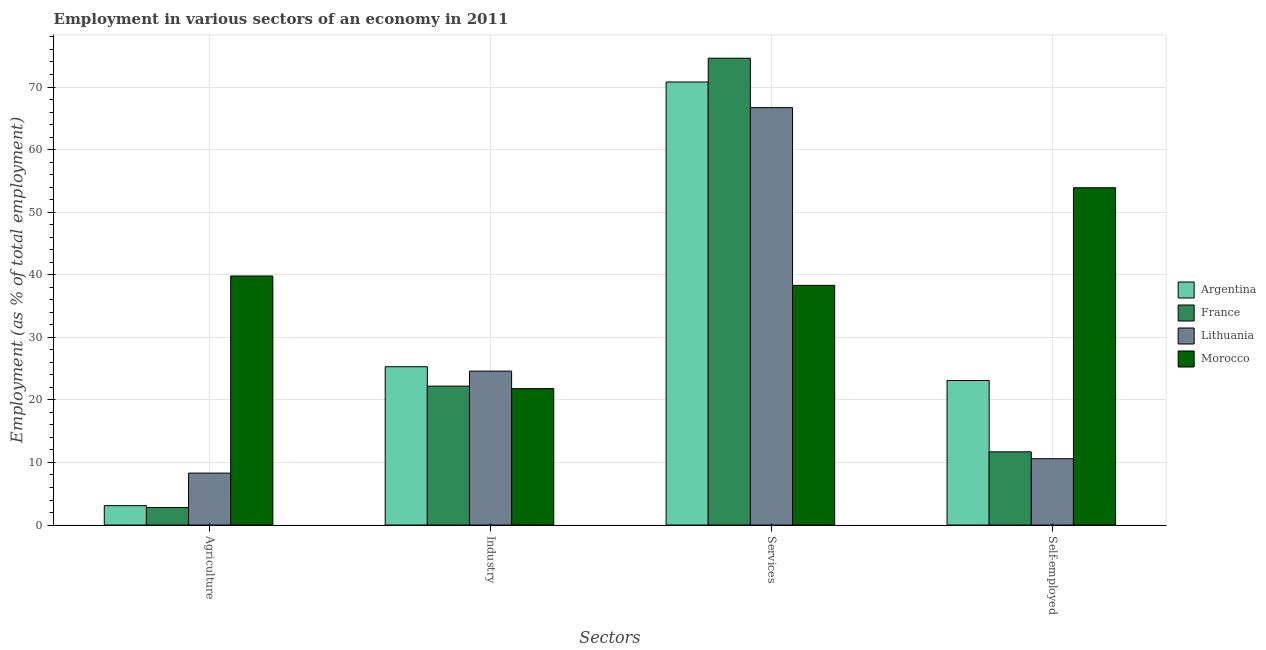Are the number of bars on each tick of the X-axis equal?
Keep it short and to the point. Yes. How many bars are there on the 2nd tick from the left?
Make the answer very short. 4. What is the label of the 3rd group of bars from the left?
Keep it short and to the point. Services. What is the percentage of self employed workers in France?
Make the answer very short. 11.7. Across all countries, what is the maximum percentage of self employed workers?
Your response must be concise. 53.9. Across all countries, what is the minimum percentage of workers in agriculture?
Provide a succinct answer. 2.8. In which country was the percentage of workers in agriculture maximum?
Offer a very short reply. Morocco. In which country was the percentage of workers in industry minimum?
Your answer should be compact. Morocco. What is the total percentage of workers in services in the graph?
Offer a very short reply. 250.4. What is the difference between the percentage of workers in services in Lithuania and that in Morocco?
Offer a terse response. 28.4. What is the difference between the percentage of workers in services in France and the percentage of self employed workers in Lithuania?
Provide a short and direct response. 64. What is the average percentage of workers in agriculture per country?
Ensure brevity in your answer.  13.5. What is the difference between the percentage of workers in industry and percentage of workers in services in Lithuania?
Give a very brief answer. -42.1. What is the ratio of the percentage of workers in services in Lithuania to that in Argentina?
Provide a succinct answer. 0.94. Is the difference between the percentage of workers in services in Morocco and Argentina greater than the difference between the percentage of workers in industry in Morocco and Argentina?
Offer a terse response. No. What is the difference between the highest and the second highest percentage of workers in industry?
Ensure brevity in your answer.  0.7. What is the difference between the highest and the lowest percentage of workers in agriculture?
Give a very brief answer. 37. In how many countries, is the percentage of self employed workers greater than the average percentage of self employed workers taken over all countries?
Offer a terse response. 1. Is it the case that in every country, the sum of the percentage of self employed workers and percentage of workers in agriculture is greater than the sum of percentage of workers in services and percentage of workers in industry?
Your response must be concise. No. Are all the bars in the graph horizontal?
Give a very brief answer. No. Does the graph contain any zero values?
Your answer should be very brief. No. Does the graph contain grids?
Your response must be concise. Yes. Where does the legend appear in the graph?
Your response must be concise. Center right. How are the legend labels stacked?
Offer a terse response. Vertical. What is the title of the graph?
Make the answer very short. Employment in various sectors of an economy in 2011. What is the label or title of the X-axis?
Offer a very short reply. Sectors. What is the label or title of the Y-axis?
Ensure brevity in your answer.  Employment (as % of total employment). What is the Employment (as % of total employment) in Argentina in Agriculture?
Offer a terse response. 3.1. What is the Employment (as % of total employment) in France in Agriculture?
Your answer should be compact. 2.8. What is the Employment (as % of total employment) in Lithuania in Agriculture?
Make the answer very short. 8.3. What is the Employment (as % of total employment) of Morocco in Agriculture?
Provide a succinct answer. 39.8. What is the Employment (as % of total employment) of Argentina in Industry?
Give a very brief answer. 25.3. What is the Employment (as % of total employment) in France in Industry?
Provide a succinct answer. 22.2. What is the Employment (as % of total employment) of Lithuania in Industry?
Ensure brevity in your answer.  24.6. What is the Employment (as % of total employment) in Morocco in Industry?
Offer a very short reply. 21.8. What is the Employment (as % of total employment) in Argentina in Services?
Your response must be concise. 70.8. What is the Employment (as % of total employment) in France in Services?
Ensure brevity in your answer.  74.6. What is the Employment (as % of total employment) of Lithuania in Services?
Give a very brief answer. 66.7. What is the Employment (as % of total employment) of Morocco in Services?
Keep it short and to the point. 38.3. What is the Employment (as % of total employment) in Argentina in Self-employed?
Offer a very short reply. 23.1. What is the Employment (as % of total employment) of France in Self-employed?
Offer a terse response. 11.7. What is the Employment (as % of total employment) in Lithuania in Self-employed?
Your response must be concise. 10.6. What is the Employment (as % of total employment) in Morocco in Self-employed?
Provide a succinct answer. 53.9. Across all Sectors, what is the maximum Employment (as % of total employment) in Argentina?
Your answer should be very brief. 70.8. Across all Sectors, what is the maximum Employment (as % of total employment) in France?
Your response must be concise. 74.6. Across all Sectors, what is the maximum Employment (as % of total employment) of Lithuania?
Your answer should be very brief. 66.7. Across all Sectors, what is the maximum Employment (as % of total employment) of Morocco?
Your response must be concise. 53.9. Across all Sectors, what is the minimum Employment (as % of total employment) of Argentina?
Your answer should be very brief. 3.1. Across all Sectors, what is the minimum Employment (as % of total employment) in France?
Offer a terse response. 2.8. Across all Sectors, what is the minimum Employment (as % of total employment) of Lithuania?
Your answer should be compact. 8.3. Across all Sectors, what is the minimum Employment (as % of total employment) of Morocco?
Provide a succinct answer. 21.8. What is the total Employment (as % of total employment) in Argentina in the graph?
Your answer should be compact. 122.3. What is the total Employment (as % of total employment) in France in the graph?
Offer a very short reply. 111.3. What is the total Employment (as % of total employment) of Lithuania in the graph?
Your response must be concise. 110.2. What is the total Employment (as % of total employment) of Morocco in the graph?
Offer a very short reply. 153.8. What is the difference between the Employment (as % of total employment) in Argentina in Agriculture and that in Industry?
Offer a terse response. -22.2. What is the difference between the Employment (as % of total employment) of France in Agriculture and that in Industry?
Provide a short and direct response. -19.4. What is the difference between the Employment (as % of total employment) of Lithuania in Agriculture and that in Industry?
Your answer should be compact. -16.3. What is the difference between the Employment (as % of total employment) of Morocco in Agriculture and that in Industry?
Your answer should be compact. 18. What is the difference between the Employment (as % of total employment) of Argentina in Agriculture and that in Services?
Provide a short and direct response. -67.7. What is the difference between the Employment (as % of total employment) of France in Agriculture and that in Services?
Make the answer very short. -71.8. What is the difference between the Employment (as % of total employment) in Lithuania in Agriculture and that in Services?
Your response must be concise. -58.4. What is the difference between the Employment (as % of total employment) of Argentina in Agriculture and that in Self-employed?
Provide a short and direct response. -20. What is the difference between the Employment (as % of total employment) of Lithuania in Agriculture and that in Self-employed?
Keep it short and to the point. -2.3. What is the difference between the Employment (as % of total employment) in Morocco in Agriculture and that in Self-employed?
Offer a very short reply. -14.1. What is the difference between the Employment (as % of total employment) in Argentina in Industry and that in Services?
Your response must be concise. -45.5. What is the difference between the Employment (as % of total employment) in France in Industry and that in Services?
Give a very brief answer. -52.4. What is the difference between the Employment (as % of total employment) of Lithuania in Industry and that in Services?
Offer a terse response. -42.1. What is the difference between the Employment (as % of total employment) in Morocco in Industry and that in Services?
Offer a very short reply. -16.5. What is the difference between the Employment (as % of total employment) of Lithuania in Industry and that in Self-employed?
Make the answer very short. 14. What is the difference between the Employment (as % of total employment) of Morocco in Industry and that in Self-employed?
Keep it short and to the point. -32.1. What is the difference between the Employment (as % of total employment) of Argentina in Services and that in Self-employed?
Keep it short and to the point. 47.7. What is the difference between the Employment (as % of total employment) of France in Services and that in Self-employed?
Your answer should be very brief. 62.9. What is the difference between the Employment (as % of total employment) in Lithuania in Services and that in Self-employed?
Provide a short and direct response. 56.1. What is the difference between the Employment (as % of total employment) of Morocco in Services and that in Self-employed?
Ensure brevity in your answer.  -15.6. What is the difference between the Employment (as % of total employment) in Argentina in Agriculture and the Employment (as % of total employment) in France in Industry?
Give a very brief answer. -19.1. What is the difference between the Employment (as % of total employment) in Argentina in Agriculture and the Employment (as % of total employment) in Lithuania in Industry?
Keep it short and to the point. -21.5. What is the difference between the Employment (as % of total employment) of Argentina in Agriculture and the Employment (as % of total employment) of Morocco in Industry?
Give a very brief answer. -18.7. What is the difference between the Employment (as % of total employment) in France in Agriculture and the Employment (as % of total employment) in Lithuania in Industry?
Provide a short and direct response. -21.8. What is the difference between the Employment (as % of total employment) in Argentina in Agriculture and the Employment (as % of total employment) in France in Services?
Ensure brevity in your answer.  -71.5. What is the difference between the Employment (as % of total employment) in Argentina in Agriculture and the Employment (as % of total employment) in Lithuania in Services?
Your answer should be very brief. -63.6. What is the difference between the Employment (as % of total employment) in Argentina in Agriculture and the Employment (as % of total employment) in Morocco in Services?
Your response must be concise. -35.2. What is the difference between the Employment (as % of total employment) in France in Agriculture and the Employment (as % of total employment) in Lithuania in Services?
Provide a succinct answer. -63.9. What is the difference between the Employment (as % of total employment) in France in Agriculture and the Employment (as % of total employment) in Morocco in Services?
Offer a very short reply. -35.5. What is the difference between the Employment (as % of total employment) in Lithuania in Agriculture and the Employment (as % of total employment) in Morocco in Services?
Give a very brief answer. -30. What is the difference between the Employment (as % of total employment) of Argentina in Agriculture and the Employment (as % of total employment) of Morocco in Self-employed?
Your answer should be compact. -50.8. What is the difference between the Employment (as % of total employment) in France in Agriculture and the Employment (as % of total employment) in Lithuania in Self-employed?
Offer a terse response. -7.8. What is the difference between the Employment (as % of total employment) of France in Agriculture and the Employment (as % of total employment) of Morocco in Self-employed?
Offer a terse response. -51.1. What is the difference between the Employment (as % of total employment) of Lithuania in Agriculture and the Employment (as % of total employment) of Morocco in Self-employed?
Provide a succinct answer. -45.6. What is the difference between the Employment (as % of total employment) in Argentina in Industry and the Employment (as % of total employment) in France in Services?
Give a very brief answer. -49.3. What is the difference between the Employment (as % of total employment) in Argentina in Industry and the Employment (as % of total employment) in Lithuania in Services?
Offer a terse response. -41.4. What is the difference between the Employment (as % of total employment) of Argentina in Industry and the Employment (as % of total employment) of Morocco in Services?
Provide a short and direct response. -13. What is the difference between the Employment (as % of total employment) in France in Industry and the Employment (as % of total employment) in Lithuania in Services?
Give a very brief answer. -44.5. What is the difference between the Employment (as % of total employment) in France in Industry and the Employment (as % of total employment) in Morocco in Services?
Your response must be concise. -16.1. What is the difference between the Employment (as % of total employment) in Lithuania in Industry and the Employment (as % of total employment) in Morocco in Services?
Keep it short and to the point. -13.7. What is the difference between the Employment (as % of total employment) in Argentina in Industry and the Employment (as % of total employment) in Morocco in Self-employed?
Make the answer very short. -28.6. What is the difference between the Employment (as % of total employment) of France in Industry and the Employment (as % of total employment) of Morocco in Self-employed?
Your answer should be compact. -31.7. What is the difference between the Employment (as % of total employment) in Lithuania in Industry and the Employment (as % of total employment) in Morocco in Self-employed?
Provide a succinct answer. -29.3. What is the difference between the Employment (as % of total employment) of Argentina in Services and the Employment (as % of total employment) of France in Self-employed?
Give a very brief answer. 59.1. What is the difference between the Employment (as % of total employment) in Argentina in Services and the Employment (as % of total employment) in Lithuania in Self-employed?
Offer a very short reply. 60.2. What is the difference between the Employment (as % of total employment) of France in Services and the Employment (as % of total employment) of Morocco in Self-employed?
Provide a short and direct response. 20.7. What is the average Employment (as % of total employment) of Argentina per Sectors?
Offer a very short reply. 30.57. What is the average Employment (as % of total employment) in France per Sectors?
Offer a very short reply. 27.82. What is the average Employment (as % of total employment) of Lithuania per Sectors?
Give a very brief answer. 27.55. What is the average Employment (as % of total employment) in Morocco per Sectors?
Your answer should be very brief. 38.45. What is the difference between the Employment (as % of total employment) of Argentina and Employment (as % of total employment) of France in Agriculture?
Make the answer very short. 0.3. What is the difference between the Employment (as % of total employment) of Argentina and Employment (as % of total employment) of Lithuania in Agriculture?
Your answer should be compact. -5.2. What is the difference between the Employment (as % of total employment) in Argentina and Employment (as % of total employment) in Morocco in Agriculture?
Provide a short and direct response. -36.7. What is the difference between the Employment (as % of total employment) in France and Employment (as % of total employment) in Lithuania in Agriculture?
Offer a terse response. -5.5. What is the difference between the Employment (as % of total employment) of France and Employment (as % of total employment) of Morocco in Agriculture?
Your answer should be compact. -37. What is the difference between the Employment (as % of total employment) of Lithuania and Employment (as % of total employment) of Morocco in Agriculture?
Provide a succinct answer. -31.5. What is the difference between the Employment (as % of total employment) in Argentina and Employment (as % of total employment) in France in Services?
Your response must be concise. -3.8. What is the difference between the Employment (as % of total employment) in Argentina and Employment (as % of total employment) in Morocco in Services?
Provide a succinct answer. 32.5. What is the difference between the Employment (as % of total employment) of France and Employment (as % of total employment) of Lithuania in Services?
Provide a succinct answer. 7.9. What is the difference between the Employment (as % of total employment) in France and Employment (as % of total employment) in Morocco in Services?
Offer a very short reply. 36.3. What is the difference between the Employment (as % of total employment) of Lithuania and Employment (as % of total employment) of Morocco in Services?
Your response must be concise. 28.4. What is the difference between the Employment (as % of total employment) in Argentina and Employment (as % of total employment) in France in Self-employed?
Your answer should be compact. 11.4. What is the difference between the Employment (as % of total employment) in Argentina and Employment (as % of total employment) in Lithuania in Self-employed?
Ensure brevity in your answer.  12.5. What is the difference between the Employment (as % of total employment) in Argentina and Employment (as % of total employment) in Morocco in Self-employed?
Provide a succinct answer. -30.8. What is the difference between the Employment (as % of total employment) in France and Employment (as % of total employment) in Morocco in Self-employed?
Ensure brevity in your answer.  -42.2. What is the difference between the Employment (as % of total employment) in Lithuania and Employment (as % of total employment) in Morocco in Self-employed?
Your response must be concise. -43.3. What is the ratio of the Employment (as % of total employment) in Argentina in Agriculture to that in Industry?
Offer a very short reply. 0.12. What is the ratio of the Employment (as % of total employment) in France in Agriculture to that in Industry?
Your answer should be very brief. 0.13. What is the ratio of the Employment (as % of total employment) of Lithuania in Agriculture to that in Industry?
Offer a very short reply. 0.34. What is the ratio of the Employment (as % of total employment) of Morocco in Agriculture to that in Industry?
Your answer should be compact. 1.83. What is the ratio of the Employment (as % of total employment) in Argentina in Agriculture to that in Services?
Ensure brevity in your answer.  0.04. What is the ratio of the Employment (as % of total employment) in France in Agriculture to that in Services?
Give a very brief answer. 0.04. What is the ratio of the Employment (as % of total employment) of Lithuania in Agriculture to that in Services?
Offer a very short reply. 0.12. What is the ratio of the Employment (as % of total employment) of Morocco in Agriculture to that in Services?
Make the answer very short. 1.04. What is the ratio of the Employment (as % of total employment) in Argentina in Agriculture to that in Self-employed?
Your response must be concise. 0.13. What is the ratio of the Employment (as % of total employment) in France in Agriculture to that in Self-employed?
Your answer should be compact. 0.24. What is the ratio of the Employment (as % of total employment) in Lithuania in Agriculture to that in Self-employed?
Provide a succinct answer. 0.78. What is the ratio of the Employment (as % of total employment) of Morocco in Agriculture to that in Self-employed?
Ensure brevity in your answer.  0.74. What is the ratio of the Employment (as % of total employment) of Argentina in Industry to that in Services?
Provide a succinct answer. 0.36. What is the ratio of the Employment (as % of total employment) in France in Industry to that in Services?
Provide a short and direct response. 0.3. What is the ratio of the Employment (as % of total employment) in Lithuania in Industry to that in Services?
Your answer should be compact. 0.37. What is the ratio of the Employment (as % of total employment) in Morocco in Industry to that in Services?
Make the answer very short. 0.57. What is the ratio of the Employment (as % of total employment) in Argentina in Industry to that in Self-employed?
Your answer should be very brief. 1.1. What is the ratio of the Employment (as % of total employment) in France in Industry to that in Self-employed?
Offer a very short reply. 1.9. What is the ratio of the Employment (as % of total employment) in Lithuania in Industry to that in Self-employed?
Offer a very short reply. 2.32. What is the ratio of the Employment (as % of total employment) of Morocco in Industry to that in Self-employed?
Ensure brevity in your answer.  0.4. What is the ratio of the Employment (as % of total employment) in Argentina in Services to that in Self-employed?
Offer a terse response. 3.06. What is the ratio of the Employment (as % of total employment) of France in Services to that in Self-employed?
Your answer should be very brief. 6.38. What is the ratio of the Employment (as % of total employment) in Lithuania in Services to that in Self-employed?
Ensure brevity in your answer.  6.29. What is the ratio of the Employment (as % of total employment) in Morocco in Services to that in Self-employed?
Your answer should be compact. 0.71. What is the difference between the highest and the second highest Employment (as % of total employment) in Argentina?
Your answer should be very brief. 45.5. What is the difference between the highest and the second highest Employment (as % of total employment) in France?
Provide a succinct answer. 52.4. What is the difference between the highest and the second highest Employment (as % of total employment) of Lithuania?
Your response must be concise. 42.1. What is the difference between the highest and the second highest Employment (as % of total employment) in Morocco?
Your response must be concise. 14.1. What is the difference between the highest and the lowest Employment (as % of total employment) in Argentina?
Give a very brief answer. 67.7. What is the difference between the highest and the lowest Employment (as % of total employment) of France?
Your response must be concise. 71.8. What is the difference between the highest and the lowest Employment (as % of total employment) in Lithuania?
Your answer should be very brief. 58.4. What is the difference between the highest and the lowest Employment (as % of total employment) of Morocco?
Your answer should be very brief. 32.1. 